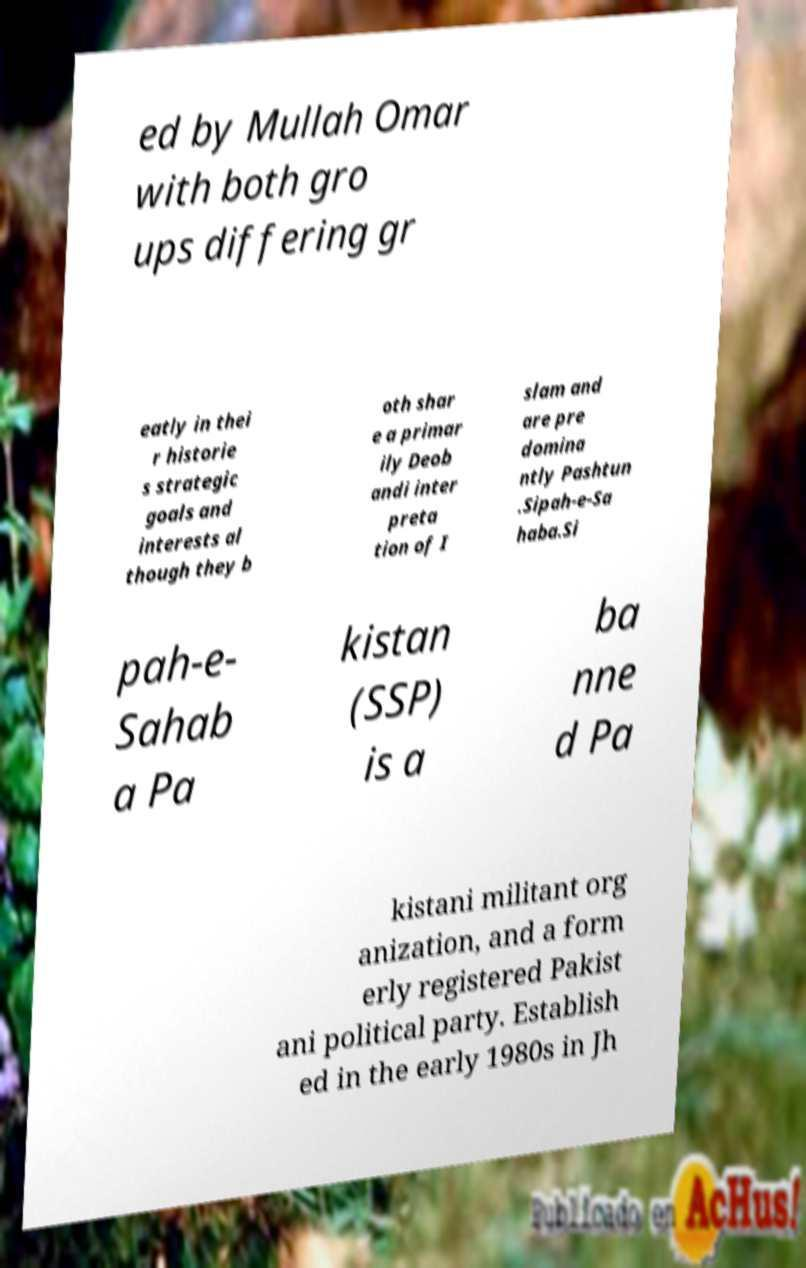Please identify and transcribe the text found in this image. ed by Mullah Omar with both gro ups differing gr eatly in thei r historie s strategic goals and interests al though they b oth shar e a primar ily Deob andi inter preta tion of I slam and are pre domina ntly Pashtun .Sipah-e-Sa haba.Si pah-e- Sahab a Pa kistan (SSP) is a ba nne d Pa kistani militant org anization, and a form erly registered Pakist ani political party. Establish ed in the early 1980s in Jh 